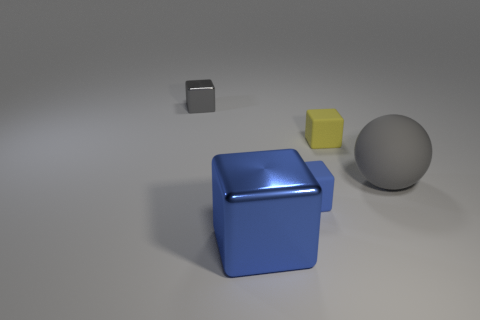Add 3 tiny yellow matte objects. How many objects exist? 8 Subtract all cubes. How many objects are left? 1 Subtract 0 cyan cubes. How many objects are left? 5 Subtract all gray matte balls. Subtract all metallic things. How many objects are left? 2 Add 1 blue metal cubes. How many blue metal cubes are left? 2 Add 3 gray objects. How many gray objects exist? 5 